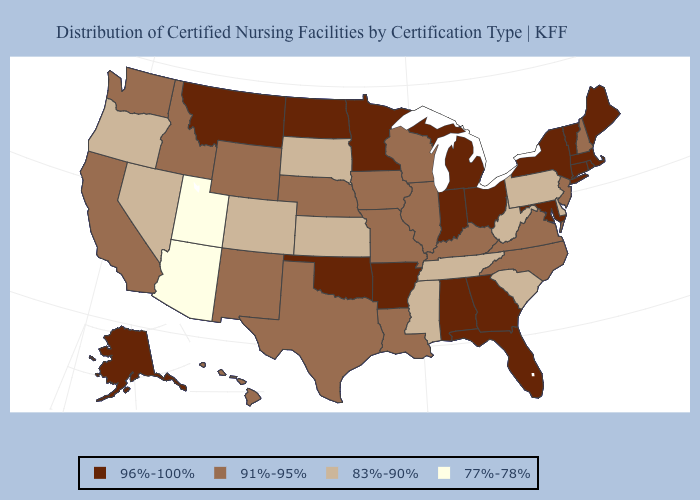Which states hav the highest value in the West?
Concise answer only. Alaska, Montana. Does Nebraska have the highest value in the MidWest?
Be succinct. No. What is the highest value in the West ?
Keep it brief. 96%-100%. What is the highest value in the MidWest ?
Concise answer only. 96%-100%. Does Maine have the highest value in the USA?
Keep it brief. Yes. What is the highest value in states that border North Carolina?
Short answer required. 96%-100%. Among the states that border Idaho , does Utah have the lowest value?
Short answer required. Yes. Name the states that have a value in the range 77%-78%?
Short answer required. Arizona, Utah. Which states hav the highest value in the Northeast?
Concise answer only. Connecticut, Maine, Massachusetts, New York, Rhode Island, Vermont. What is the value of Arkansas?
Keep it brief. 96%-100%. Among the states that border Oregon , which have the lowest value?
Write a very short answer. Nevada. Name the states that have a value in the range 91%-95%?
Concise answer only. California, Hawaii, Idaho, Illinois, Iowa, Kentucky, Louisiana, Missouri, Nebraska, New Hampshire, New Jersey, New Mexico, North Carolina, Texas, Virginia, Washington, Wisconsin, Wyoming. Does Kansas have the highest value in the USA?
Answer briefly. No. Does Mississippi have the lowest value in the South?
Short answer required. Yes. What is the highest value in the USA?
Quick response, please. 96%-100%. 